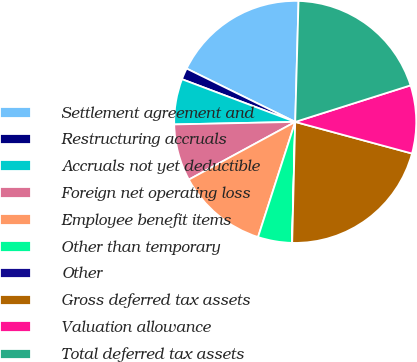Convert chart. <chart><loc_0><loc_0><loc_500><loc_500><pie_chart><fcel>Settlement agreement and<fcel>Restructuring accruals<fcel>Accruals not yet deductible<fcel>Foreign net operating loss<fcel>Employee benefit items<fcel>Other than temporary<fcel>Other<fcel>Gross deferred tax assets<fcel>Valuation allowance<fcel>Total deferred tax assets<nl><fcel>18.17%<fcel>1.53%<fcel>6.07%<fcel>7.58%<fcel>12.12%<fcel>4.55%<fcel>0.02%<fcel>21.19%<fcel>9.09%<fcel>19.68%<nl></chart> 